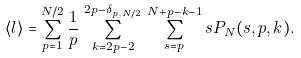<formula> <loc_0><loc_0><loc_500><loc_500>\langle l \rangle = \sum _ { p = 1 } ^ { N / 2 } \frac { 1 } { p } \, \sum _ { k = 2 p - 2 } ^ { 2 p - \delta _ { p , N / 2 } } \, \sum _ { s = p } ^ { N + p - k - 1 } s P _ { N } ( s , p , k ) .</formula> 